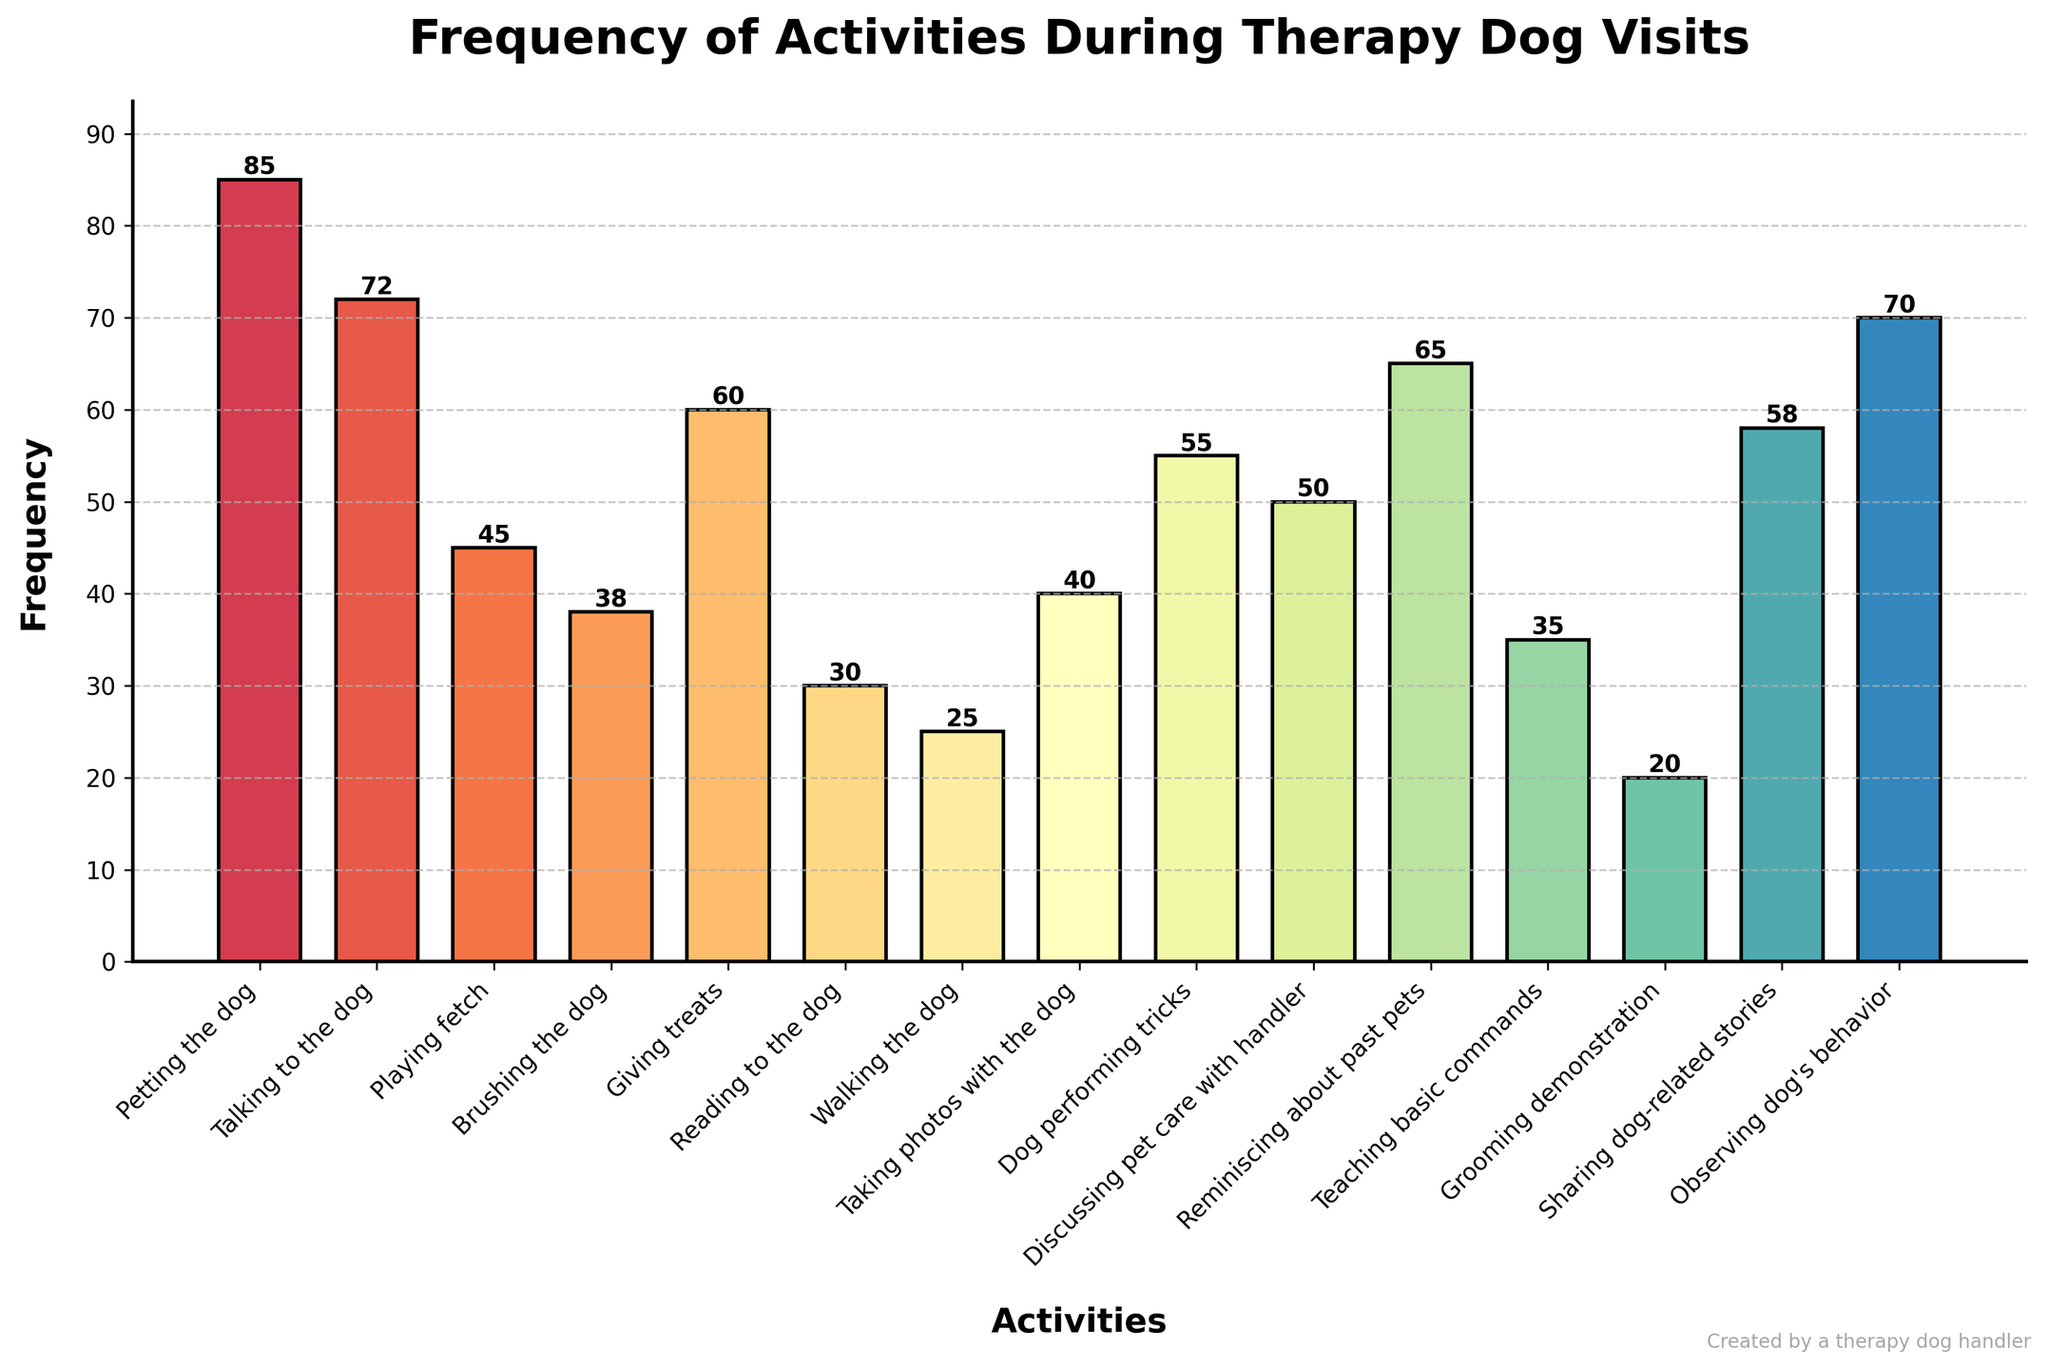What activity is performed most frequently during therapy dog visits? The activity with the tallest bar in the bar chart represents the most frequently performed activity. "Petting the dog" has the highest frequency at 85.
Answer: Petting the dog Which activities have a frequency of over 60? By observing the heights of the bars that align with the frequency axis, we can see that "Petting the dog", "Talking to the dog", "Giving treats", "Reminiscing about past pets", and "Observing dog's behavior" have frequencies over 60.
Answer: Petting the dog, Talking to the dog, Giving treats, Reminiscing about past pets, Observing dog's behavior What is the frequency difference between "Playing fetch" and "Dog performing tricks"? The frequency of "Playing fetch" is 45 and "Dog performing tricks" is 55. The difference is calculated as 55 - 45.
Answer: 10 Which activity is performed less frequently than "Reading to the dog" but more frequently than "Grooming demonstration"? "Reading to the dog" has a frequency of 30 and "Grooming demonstration" has a frequency of 20. The activity between these frequencies is "Walking the dog" with a frequency of 25.
Answer: Walking the dog Are the frequencies of "Teaching basic commands" and "Brushing the dog" equal? Comparing the heights of the bars representing these activities, "Teaching basic commands" has a frequency of 35, and "Brushing the dog" has a frequency of 38. They are not equal.
Answer: No Which activity is performed more frequently: "Observing dog's behavior" or "Discussing pet care with handler"? By comparing the heights of the respective bars, "Observing dog's behavior" has a frequency of 70 and "Discussing pet care with handler" has a frequency of 50.
Answer: Observing dog's behavior What is the total combined frequency of "Talking to the dog" and "Giving treats"? The frequency of "Talking to the dog" is 72 and "Giving treats" is 60. Adding these together gives 72 + 60.
Answer: 132 Which activities have a frequency exactly divisible by 10? "Petting the dog" has a frequency of 85 (not divisible by 10), "Talking to the dog" 72 (not divisible), "Playing fetch" 45 (not divisible), "Brushing the dog" 38 (not divisible), "Giving treats" 60 (divisible by 10), "Reading to the dog" 30 (divisible by 10), "Walking the dog" 25 (not divisible), "Taking photos with the dog" 40 (divisible by 10), "Dog performing tricks" 55 (not divisible), "Discussing pet care with handler" 50 (divisible by 10), "Reminiscing about past pets" 65 (not divisible), "Teaching basic commands" 35 (not divisible), "Grooming demonstration" 20 (divisible by 10), "Sharing dog-related stories" 58 (not divisible), and "Observing dog's behavior" 70 (divisible by 10). So, activities with frequencies divisible by 10 are "Giving treats", "Reading to the dog", "Taking photos with the dog", "Discussing pet care with handler", "Grooming demonstration", and "Observing dog's behavior".
Answer: Giving treats, Reading to the dog, Taking photos with the dog, Discussing pet care with handler, Grooming demonstration, Observing dog's behavior Which activity involving physical interaction with the dog has the lowest frequency? Activities involving physical interaction are "Petting the dog," "Playing fetch," "Brushing the dog," "Giving treats," "Walking the dog," "Taking photos with the dog," "Dog performing tricks," "Teaching basic commands," and "Grooming demonstration." Among these, "Grooming demonstration" has the lowest frequency at 20.
Answer: Grooming demonstration What is the average frequency of the top three most performed activities? The top three activities are "Petting the dog" (85), "Talking to the dog" (72), and "Observing dog's behavior" (70). Their average frequency is calculated as (85 + 72 + 70) / 3.
Answer: 75.67 